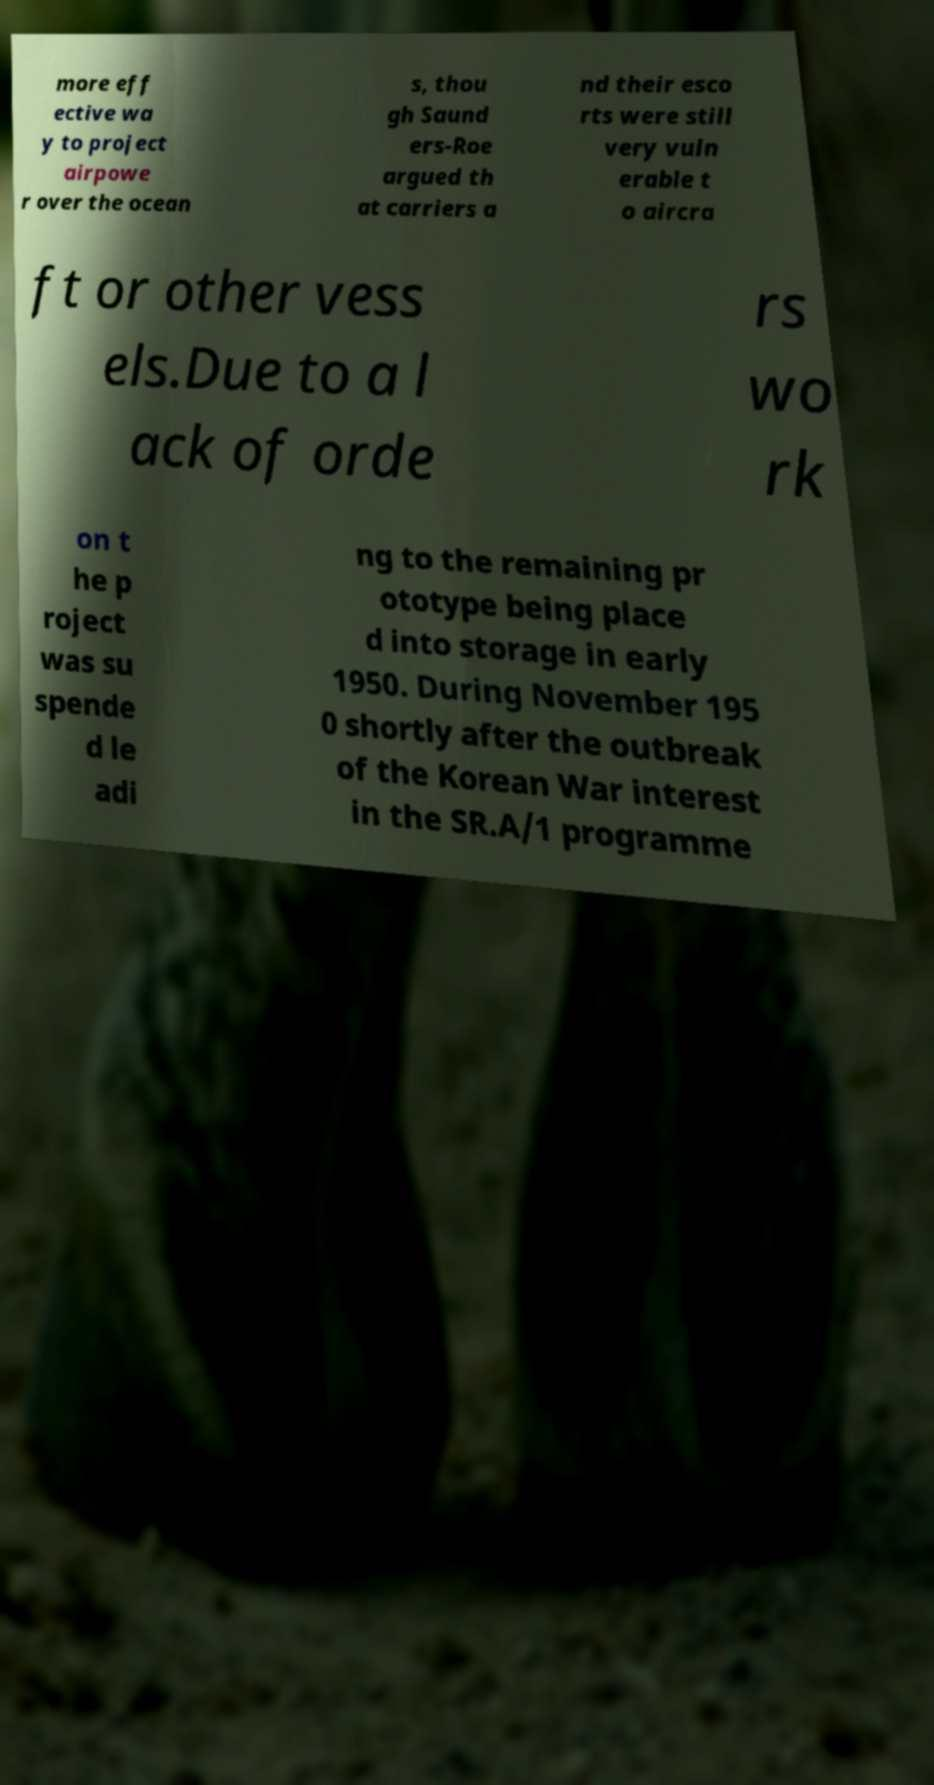For documentation purposes, I need the text within this image transcribed. Could you provide that? more eff ective wa y to project airpowe r over the ocean s, thou gh Saund ers-Roe argued th at carriers a nd their esco rts were still very vuln erable t o aircra ft or other vess els.Due to a l ack of orde rs wo rk on t he p roject was su spende d le adi ng to the remaining pr ototype being place d into storage in early 1950. During November 195 0 shortly after the outbreak of the Korean War interest in the SR.A/1 programme 